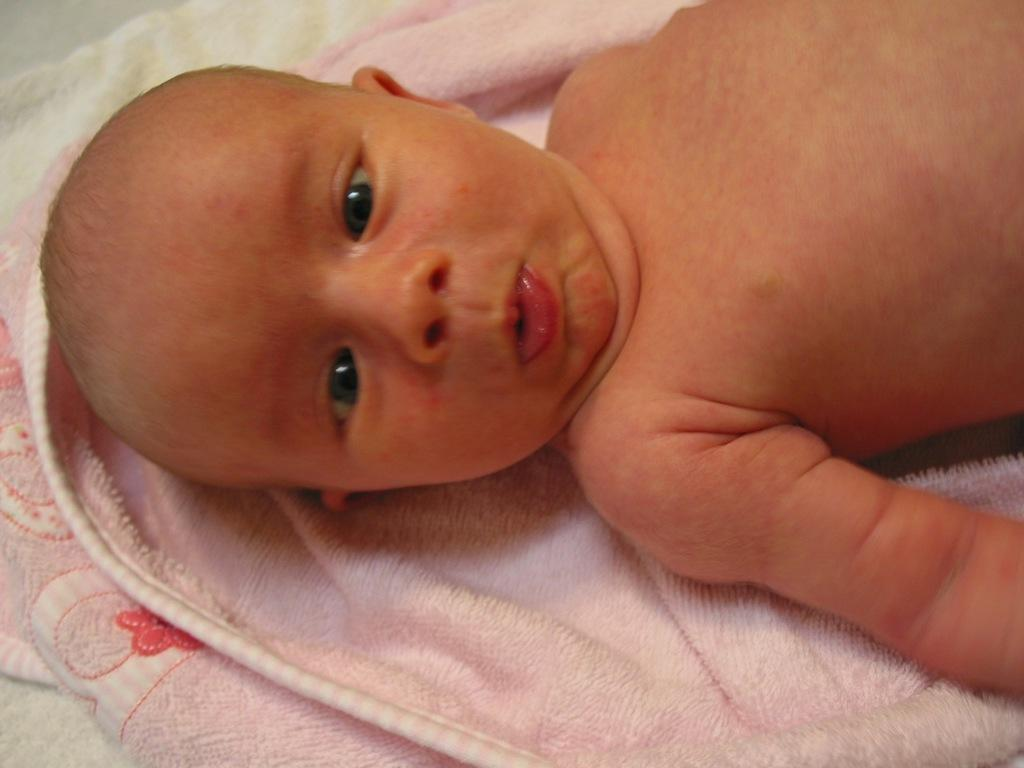What is the main subject of the image? There is a baby in the image. What is the baby lying on? The baby is lying on a towel cloth. What type of elbow can be seen in the image? There is no elbow present in the image; it features a baby lying on a towel cloth. 